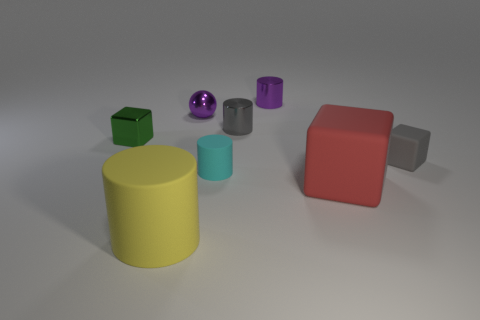Is there any other thing that is made of the same material as the green object?
Offer a very short reply. Yes. What number of cylinders are the same color as the small rubber block?
Offer a terse response. 1. There is a matte cube in front of the cyan rubber thing; is it the same size as the matte thing to the left of the tiny ball?
Offer a terse response. Yes. Is there a small cyan thing made of the same material as the tiny gray cube?
Keep it short and to the point. Yes. The green thing is what shape?
Your answer should be very brief. Cube. What is the shape of the small purple metal thing on the left side of the tiny cylinder that is on the left side of the gray cylinder?
Give a very brief answer. Sphere. What number of other things are the same shape as the big yellow matte thing?
Your response must be concise. 3. There is a yellow cylinder that is in front of the gray thing in front of the small shiny block; what size is it?
Your response must be concise. Large. Are there any large brown spheres?
Your answer should be very brief. No. What number of purple shiny things are in front of the small purple object right of the cyan rubber object?
Your answer should be very brief. 1. 